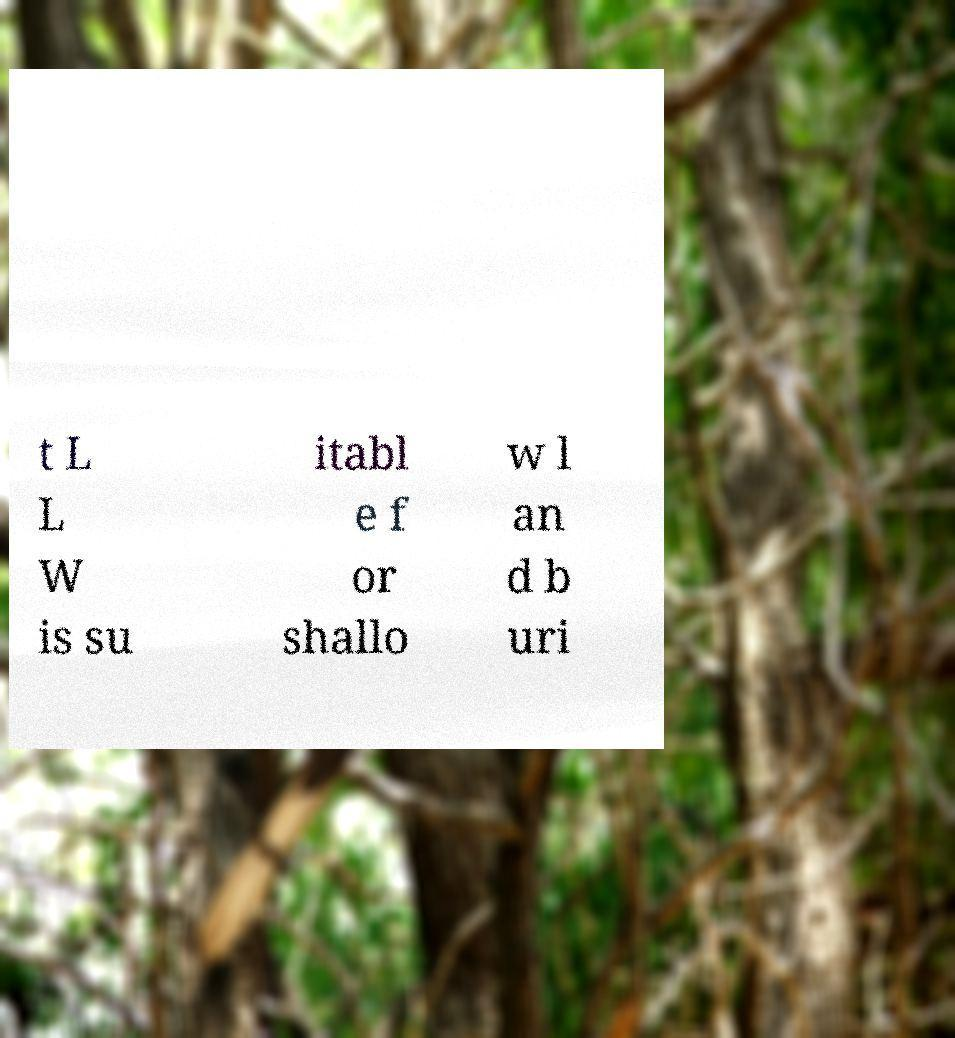Could you extract and type out the text from this image? t L L W is su itabl e f or shallo w l an d b uri 